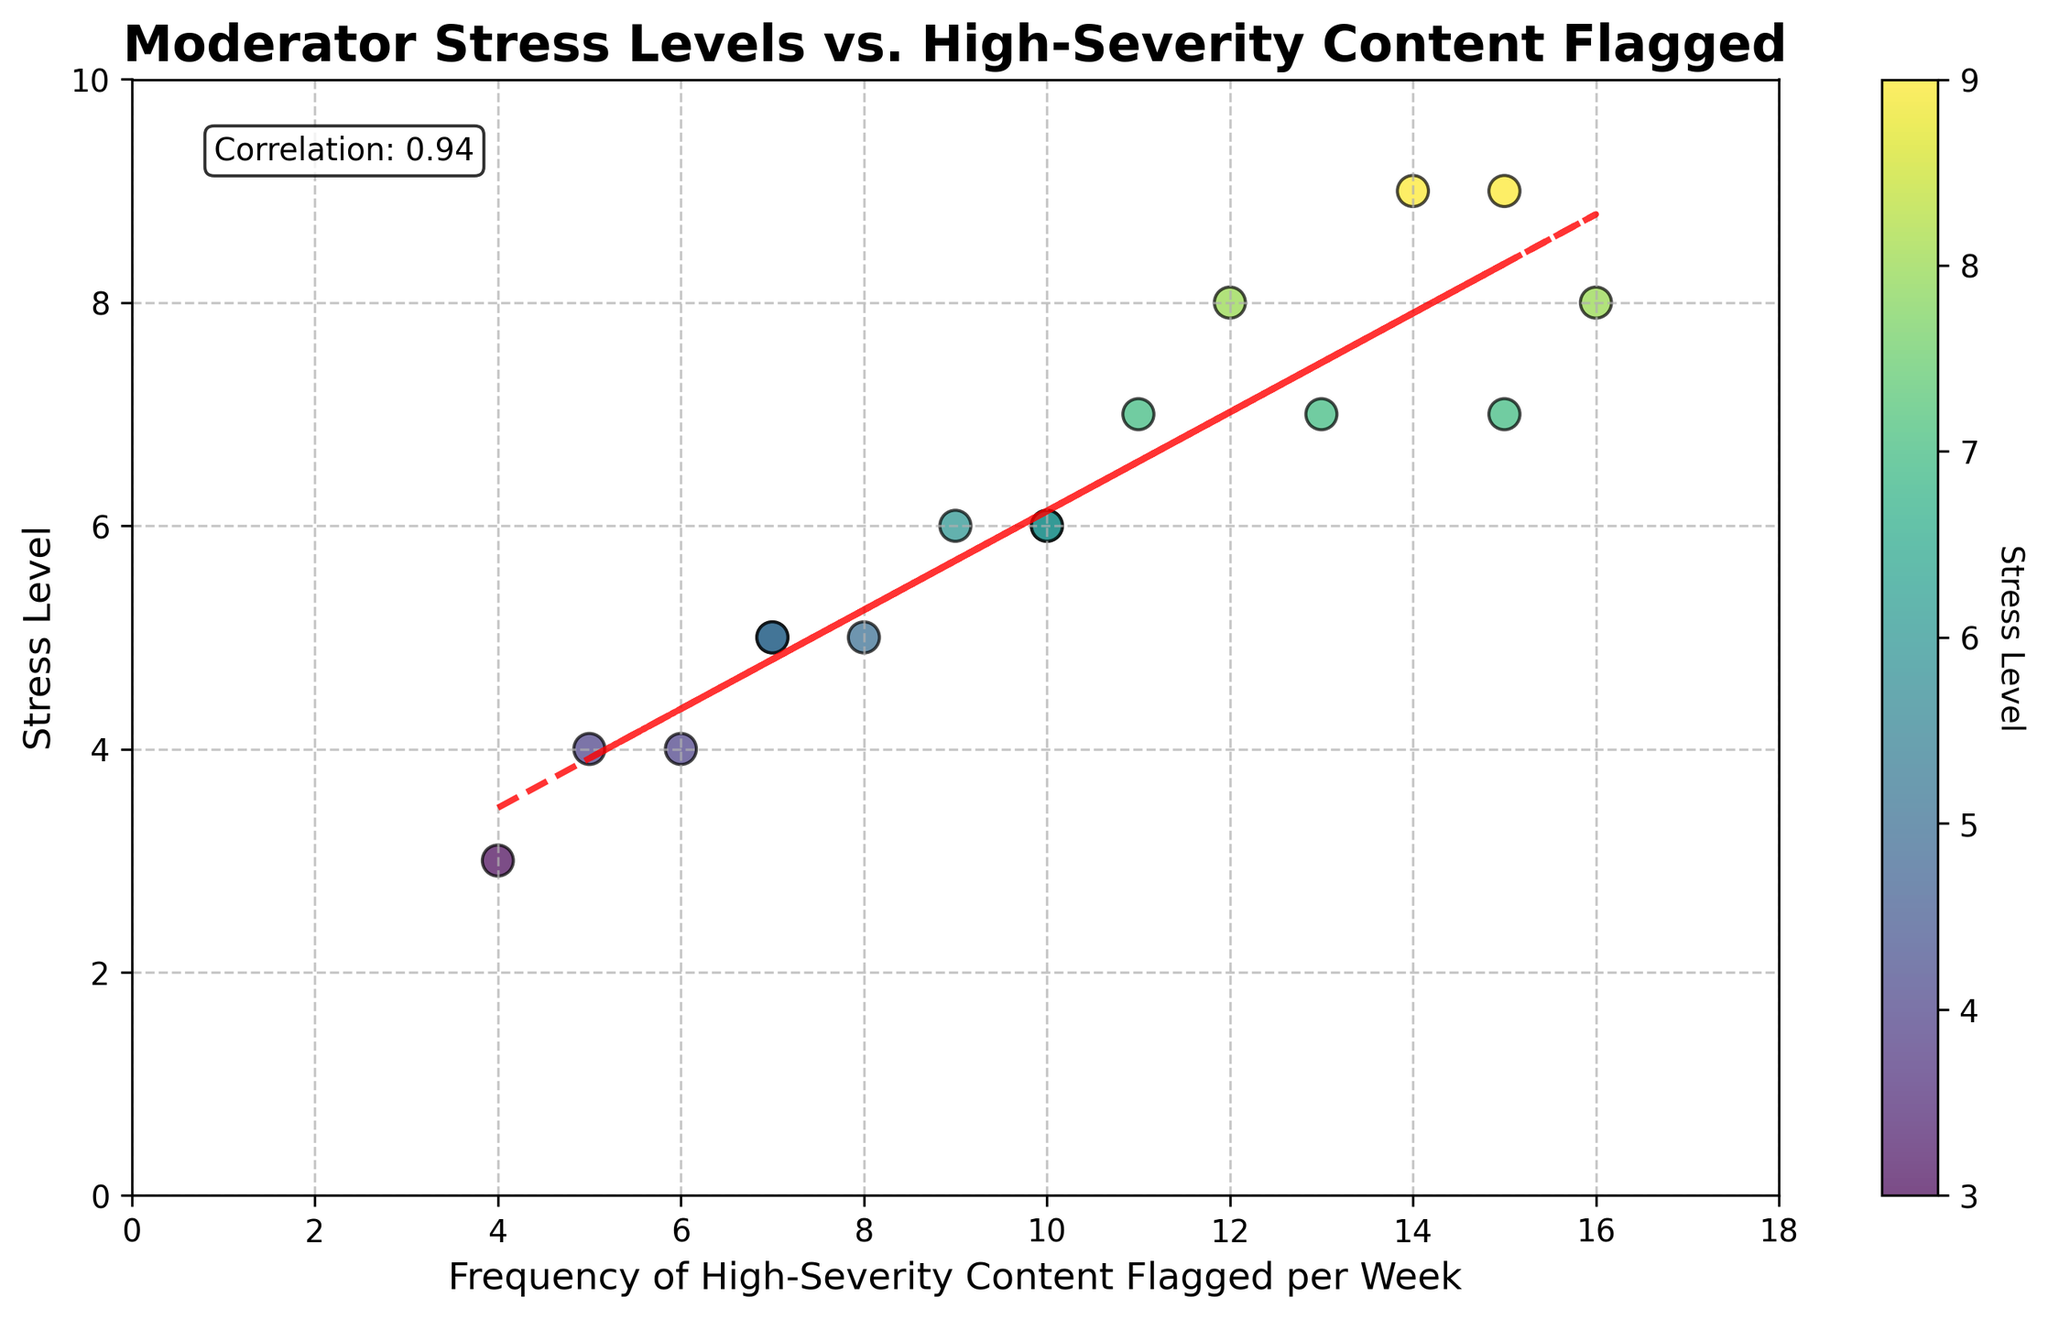What is the title of the plot? The title is a basic element of the plot and is usually displayed at the top. It provides a summary of what the plot is about.
Answer: Moderator Stress Levels vs. High-Severity Content Flagged What are the x-axis and y-axis labels? The x-axis and y-axis labels are basic elements that describe what each axis represents. The x-axis label is at the bottom, and the y-axis label is on the left side of the plot.
Answer: Frequency of High-Severity Content Flagged per Week and Stress Level How many data points are plotted in the scatter plot? Counting the individual scatter data points directly from the plot, we can determine the total number of data points.
Answer: 16 What is the correlation coefficient between the frequency of high-severity content flagged and stress levels? The correlation coefficient is explicitly provided in the plot text box. It is a measure of the strength and direction of the linear relationship between two variables.
Answer: 0.91 What is the highest stress level observed in the plot, and at what frequency of high-severity content flagged does it occur? To find this, look for the highest point on the y-axis and check its corresponding x-axis value.
Answer: 9, 15 content flagged Comparing the data points with a stress level of 8, what are the corresponding frequencies of high-severity content flagged? Locate the data points on the scatter plot where the y-values (stress level) are 8 and observe the corresponding x-values (frequency of content flagged).
Answer: 12 and 16 What is the trend line equation represented in the plot? The trend line equation can usually be inferred from the data plotted but is represented on the plot as a dotted line describing the relationship. Use the slope and intercept values from the trend line trend equation \( y = mx + b \).
Answer: y = 0.96x + 2.45 What is the average stress level for frequencies of high-severity content flagged greater than or equal to 10? Identify the data points with frequencies ≥ 10, sum their stress levels, and divide by the number of those points.
Answer: \((6 + 8 + 7 + 9 + 7 + 9 + 8)/7 = 54/7 ≈ 7.71\) What general trend can be observed between stress levels and the frequency of high-severity content flagged per week? Observing the trend line, it shows whether there is an increasing or decreasing general movement.
Answer: As the frequency of high-severity content flagged increases, the stress level generally increases 